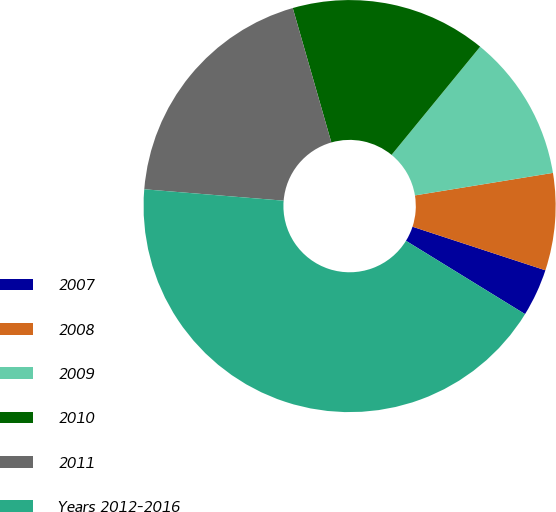<chart> <loc_0><loc_0><loc_500><loc_500><pie_chart><fcel>2007<fcel>2008<fcel>2009<fcel>2010<fcel>2011<fcel>Years 2012-2016<nl><fcel>3.74%<fcel>7.62%<fcel>11.5%<fcel>15.37%<fcel>19.25%<fcel>42.51%<nl></chart> 